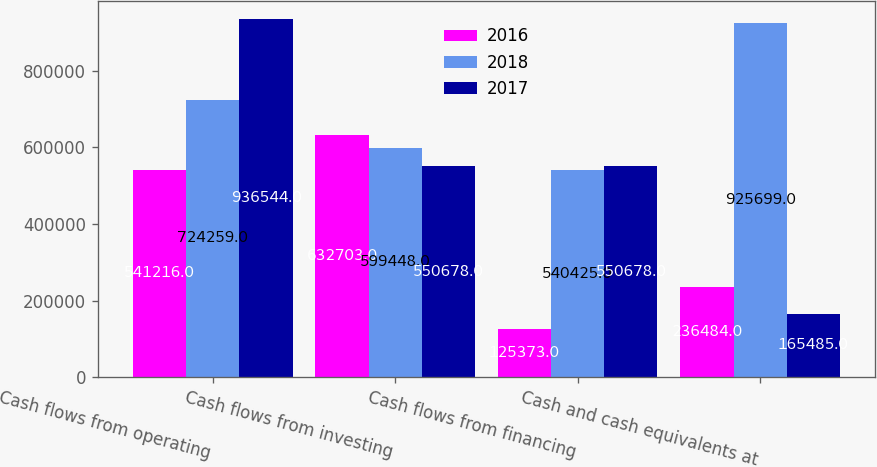Convert chart to OTSL. <chart><loc_0><loc_0><loc_500><loc_500><stacked_bar_chart><ecel><fcel>Cash flows from operating<fcel>Cash flows from investing<fcel>Cash flows from financing<fcel>Cash and cash equivalents at<nl><fcel>2016<fcel>541216<fcel>632703<fcel>125373<fcel>236484<nl><fcel>2018<fcel>724259<fcel>599448<fcel>540425<fcel>925699<nl><fcel>2017<fcel>936544<fcel>550678<fcel>550678<fcel>165485<nl></chart> 